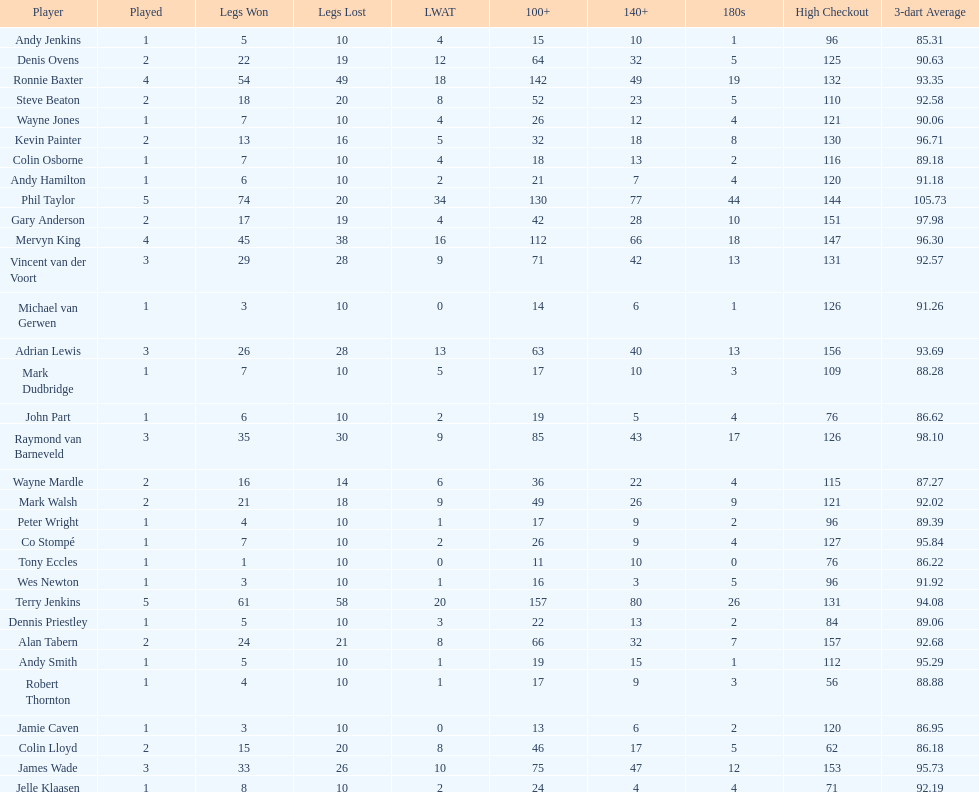What are the number of legs lost by james wade? 26. 